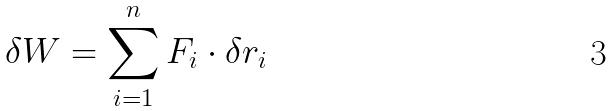<formula> <loc_0><loc_0><loc_500><loc_500>\delta W = \sum _ { i = 1 } ^ { n } F _ { i } \cdot \delta r _ { i }</formula> 